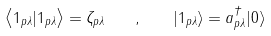Convert formula to latex. <formula><loc_0><loc_0><loc_500><loc_500>\left \langle 1 _ { p \lambda } | 1 _ { p \lambda } \right \rangle = \zeta _ { p \lambda } \quad , \quad | 1 _ { p \lambda } \rangle = a _ { p \lambda } ^ { \dagger } | 0 \rangle</formula> 